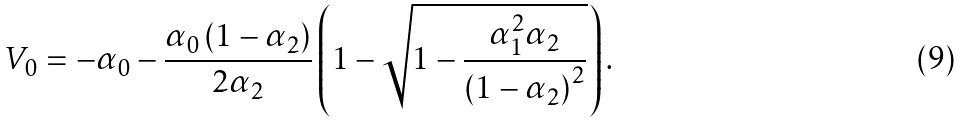<formula> <loc_0><loc_0><loc_500><loc_500>V _ { 0 } = - \alpha _ { 0 } - \frac { \alpha _ { 0 } \left ( 1 - \alpha _ { 2 } \right ) } { 2 \alpha _ { 2 } } \left ( 1 - \sqrt { 1 - \frac { \alpha _ { 1 } ^ { 2 } \alpha _ { 2 } } { \left ( 1 - \alpha _ { 2 } \right ) ^ { 2 } } } \right ) .</formula> 